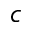<formula> <loc_0><loc_0><loc_500><loc_500>c</formula> 